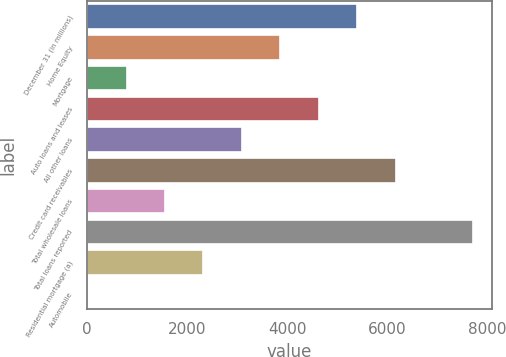<chart> <loc_0><loc_0><loc_500><loc_500><bar_chart><fcel>December 31 (in millions)<fcel>Home Equity<fcel>Mortgage<fcel>Auto loans and leases<fcel>All other loans<fcel>Credit card receivables<fcel>Total wholesale loans<fcel>Total loans reported<fcel>Residential mortgage (a)<fcel>Automobile<nl><fcel>5405<fcel>3865<fcel>785<fcel>4635<fcel>3095<fcel>6175<fcel>1555<fcel>7715<fcel>2325<fcel>15<nl></chart> 